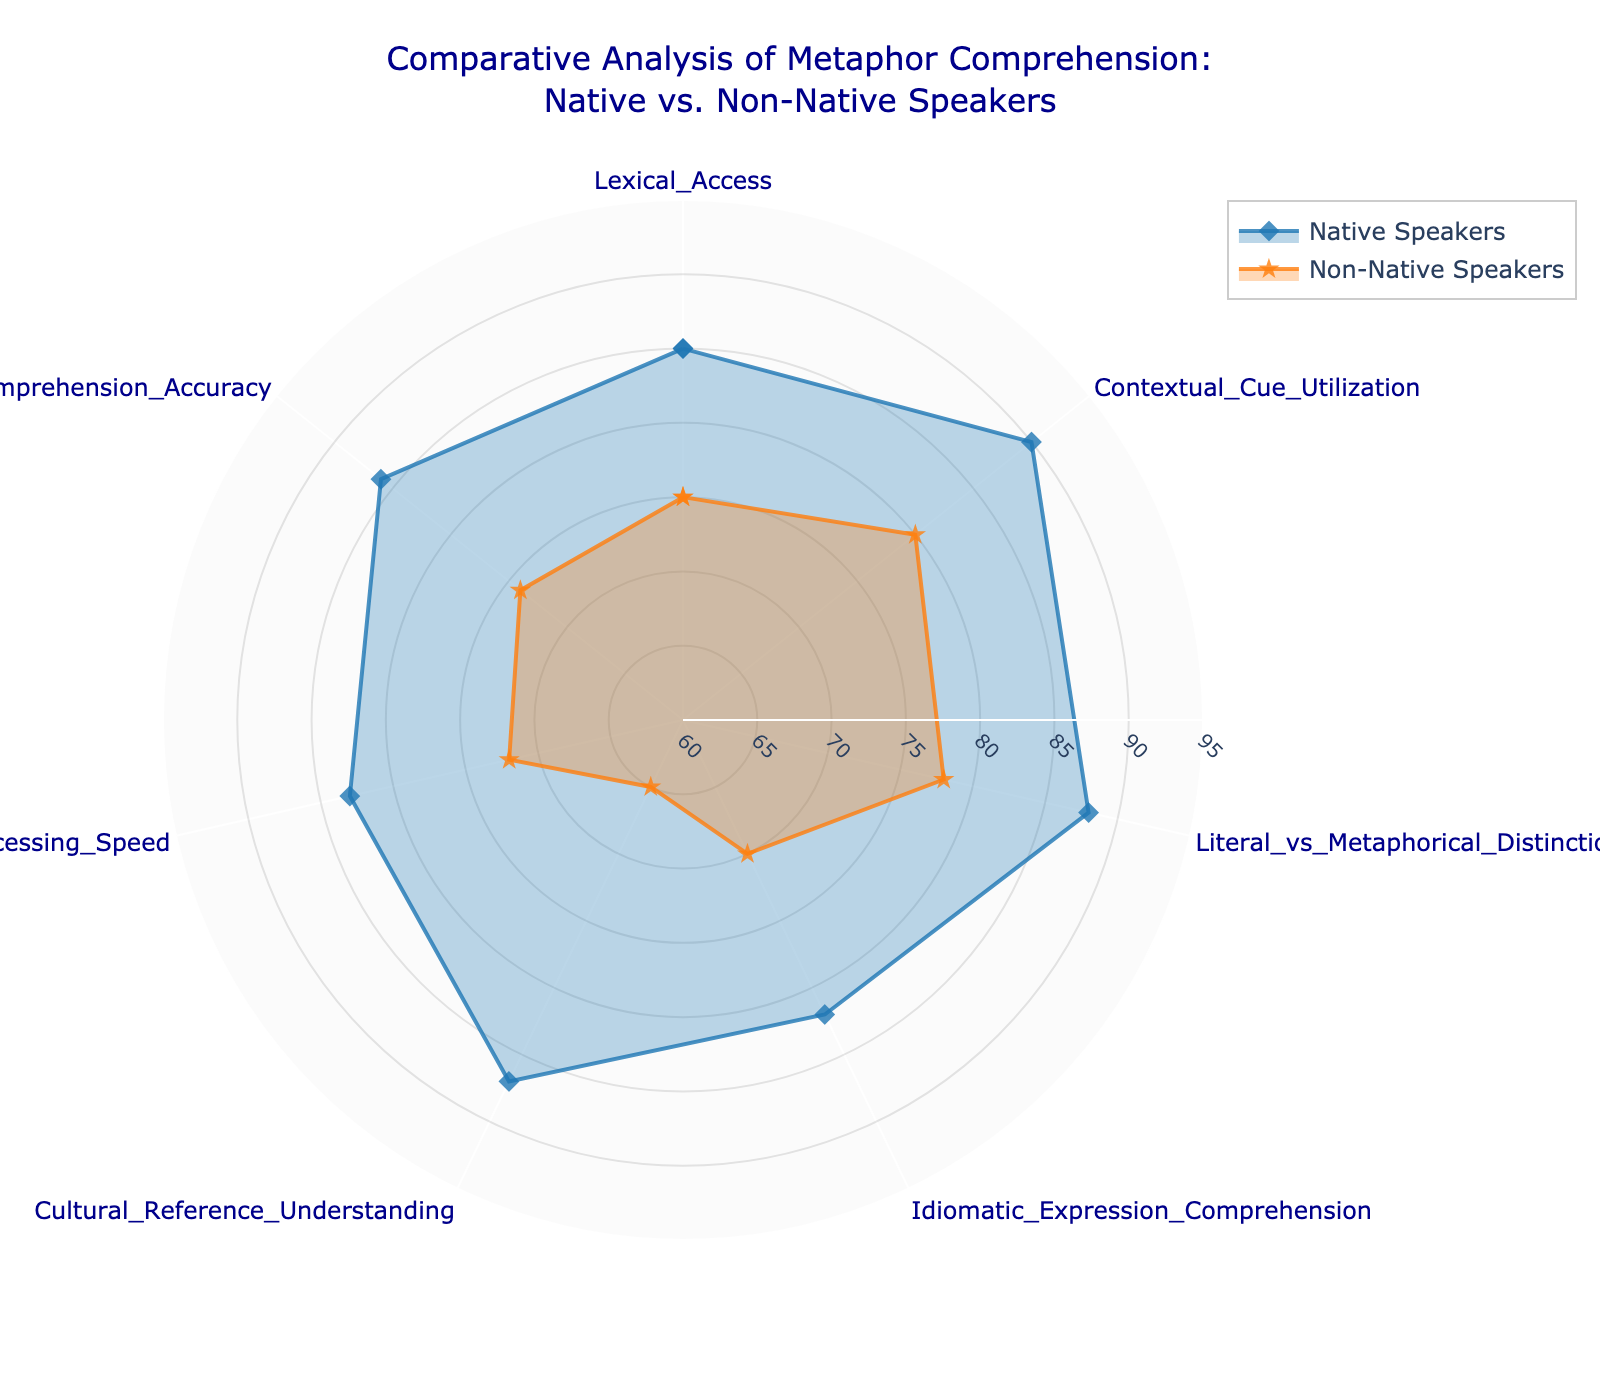What is the title of the chart? The title can be found at the top center of the chart.
Answer: Comparative Analysis of Metaphor Comprehension: Native vs. Non-Native Speakers Which category has the lowest score for non-native speakers? Look at the scores for the non-native speakers and find the smallest value.
Answer: Cultural Reference Understanding How many categories are compared in the radar chart? Count the different categories listed around the radar chart.
Answer: 7 What is the range of the radial axis? The range of the radial axis is typically marked along the radial lines of the chart.
Answer: 60 to 95 Which group scored higher in Idiomatic Expression Comprehension? Compare the values of both groups for the 'Idiomatic Expression Comprehension' category.
Answer: Native Speakers What is the average score for native speakers across all categories? Sum all the values for native speakers and divide by the number of categories. (85 + 90 + 88 + 82 + 87 + 83 + 86) / 7 = 87.2857
Answer: 87.29 How much higher is the score of native speakers for Cultural Reference Understanding compared to non-native speakers? Subtract the non-native score from the native score for the 'Cultural Reference Understanding' category. (87 - 65) = 22
Answer: 22 Which category has the smallest difference between the scores of native and non-native speakers? Calculate the differences for all categories and identify the smallest one. The smallest difference is for 'Lexical Access' (85 - 75) = 10
Answer: Lexical Access Is the processing speed of native speakers above or below the average for all categories? Calculate the average score for native speakers and compare it to the 'Processing Speed' score. Average: 87.29, Processing Speed: 83.
Answer: Below Which radar plot marker represents native speakers? Look at the legend and find the marker symbol/color assigned to native speakers.
Answer: Diamond 